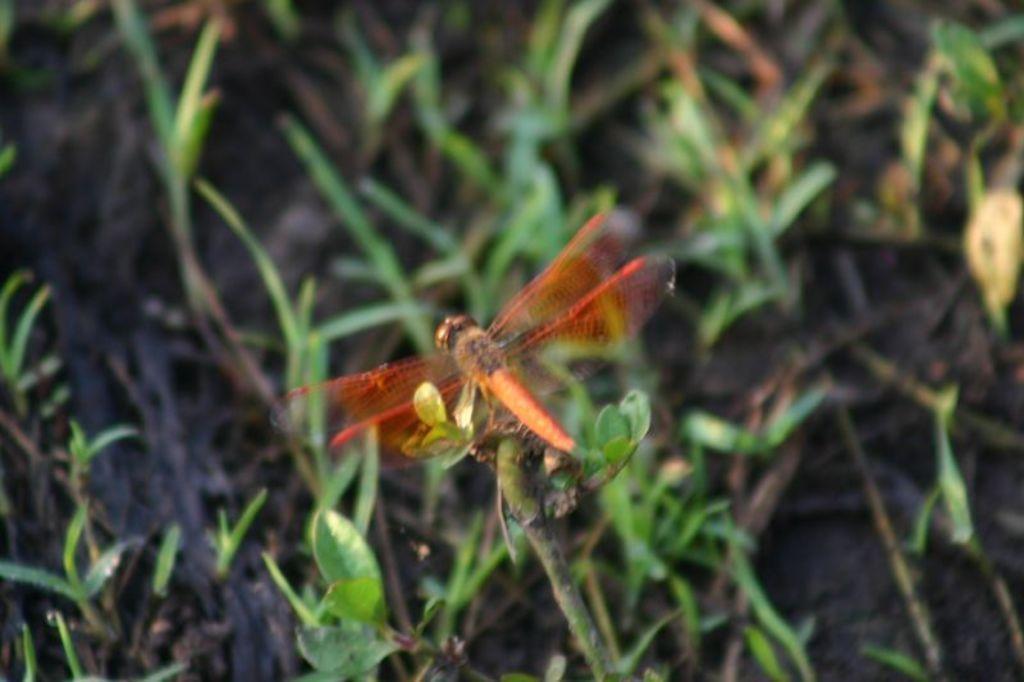How would you summarize this image in a sentence or two? In this image there is a fly on the tree stem. At the bottom there is grass. 